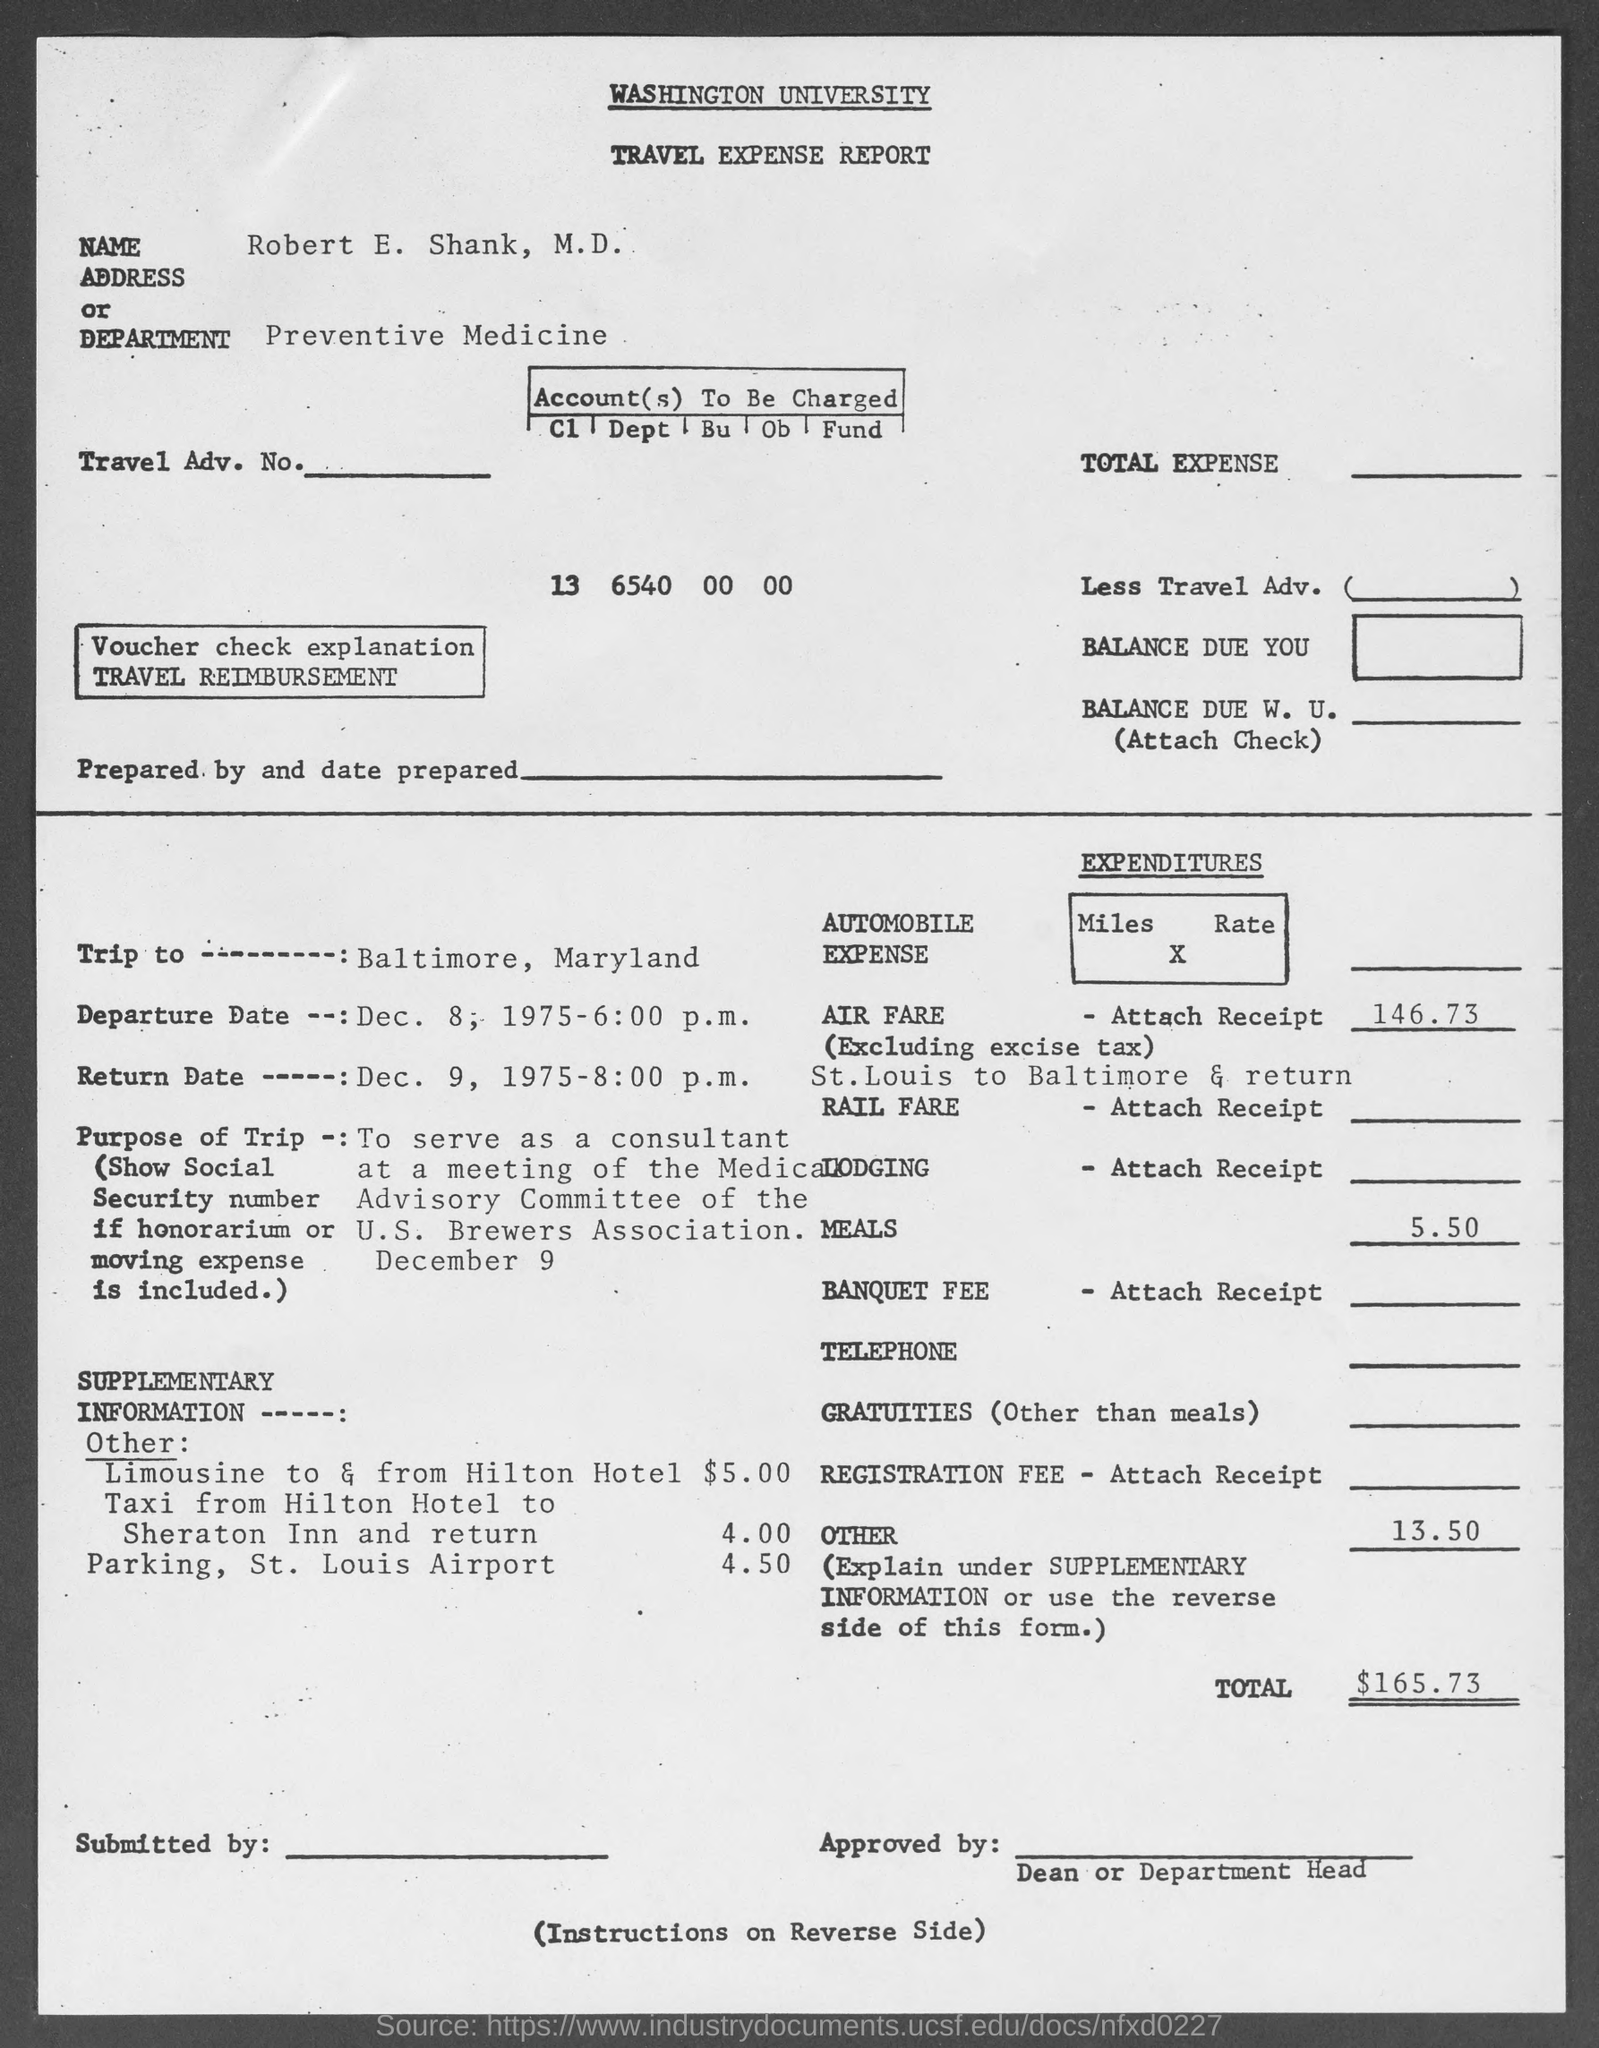Outline some significant characteristics in this image. The top of the document reads 'Washington University.' The name "Robert E. Shank, M.D." is written in the Name field. The total expenditure is $165.73. The Department Name is Preventive Medicine. 